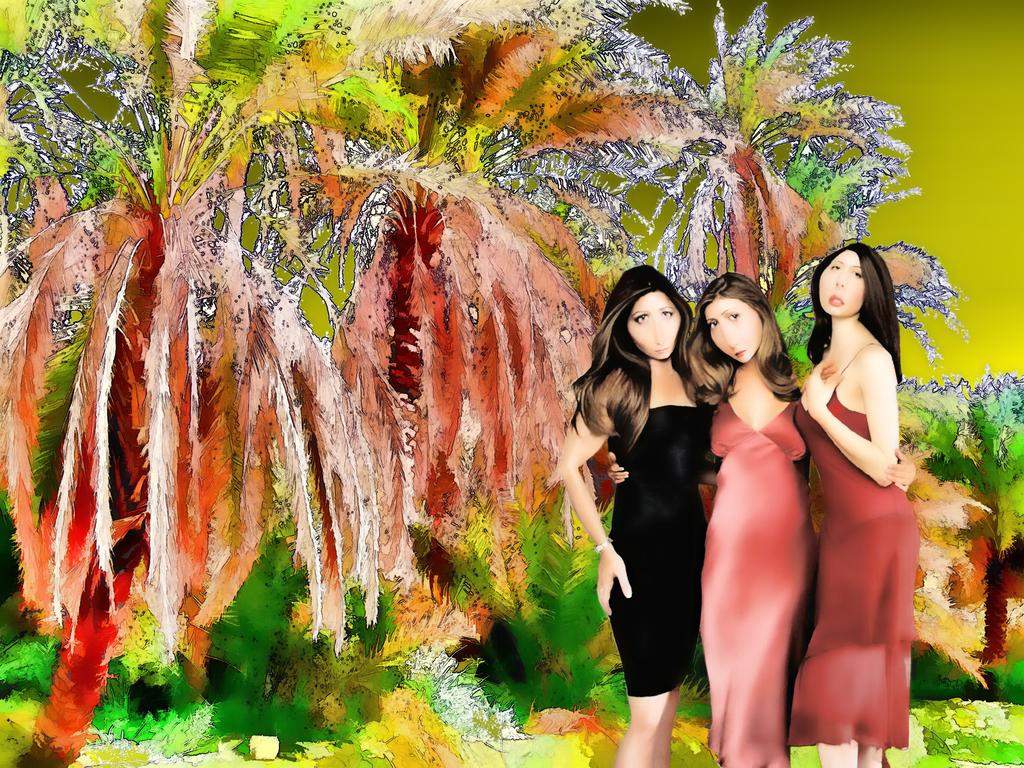What type of artwork is depicted in the image? The image is a painting. How many people are in the painting? There are three persons standing in the center of the painting. What can be seen in the background of the painting? There are trees visible in the background of the painting. Is there a farm visible in the painting? No, there is no farm present in the painting. Can you see a volcano in the background of the painting? No, there is no volcano present in the painting. 